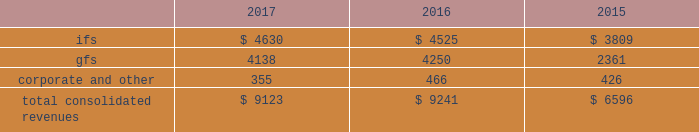2022 expand client relationships - the overall market we serve continues to gravitate beyond single-application purchases to multi-solution partnerships .
As the market dynamics shift , we expect our clients and prospects to rely more on our multidimensional service offerings .
Our leveraged solutions and processing expertise can produce meaningful value and cost savings for our clients through more efficient operating processes , improved service quality and convenience for our clients' customers .
2022 build global diversification - we continue to deploy resources in global markets where we expect to achieve meaningful scale .
Revenues by segment the table below summarizes our revenues by reporting segment ( in millions ) : .
Integrated financial solutions ( "ifs" ) the ifs segment is focused primarily on serving north american regional and community bank and savings institutions for transaction and account processing , payment solutions , channel solutions , digital channels , fraud , risk management and compliance solutions , lending and wealth and retirement solutions , and corporate liquidity , capitalizing on the continuing trend to outsource these solutions .
Clients in this segment include regional and community banks , credit unions and commercial lenders , as well as government institutions , merchants and other commercial organizations .
These markets are primarily served through integrated solutions and characterized by multi-year processing contracts that generate highly recurring revenues .
The predictable nature of cash flows generated from this segment provides opportunities for further investments in innovation , integration , information and security , and compliance in a cost-effective manner .
Our solutions in this segment include : 2022 core processing and ancillary applications .
Our core processing software applications are designed to run banking processes for our financial institution clients , including deposit and lending systems , customer management , and other central management systems , serving as the system of record for processed activity .
Our diverse selection of market- focused core systems enables fis to compete effectively in a wide range of markets .
We also offer a number of services that are ancillary to the primary applications listed above , including branch automation , back-office support systems and compliance support .
2022 digital solutions , including internet , mobile and ebanking .
Our comprehensive suite of retail delivery applications enables financial institutions to integrate and streamline customer-facing operations and back-office processes , thereby improving customer interaction across all channels ( e.g. , branch offices , internet , atm , mobile , call centers ) .
Fis' focus on consumer access has driven significant market innovation in this area , with multi-channel and multi-host solutions and a strategy that provides tight integration of services and a seamless customer experience .
Fis is a leader in mobile banking solutions and electronic banking enabling clients to manage banking and payments through the internet , mobile devices , accounting software and telephone .
Our corporate electronic banking solutions provide commercial treasury capabilities including cash management services and multi-bank collection and disbursement services that address the specialized needs of corporate clients .
Fis systems provide full accounting and reconciliation for such transactions , serving also as the system of record. .
What percentage of total consolidated revenues was gfs segment in 2016? 
Computations: (4250 / 9241)
Answer: 0.45991. 